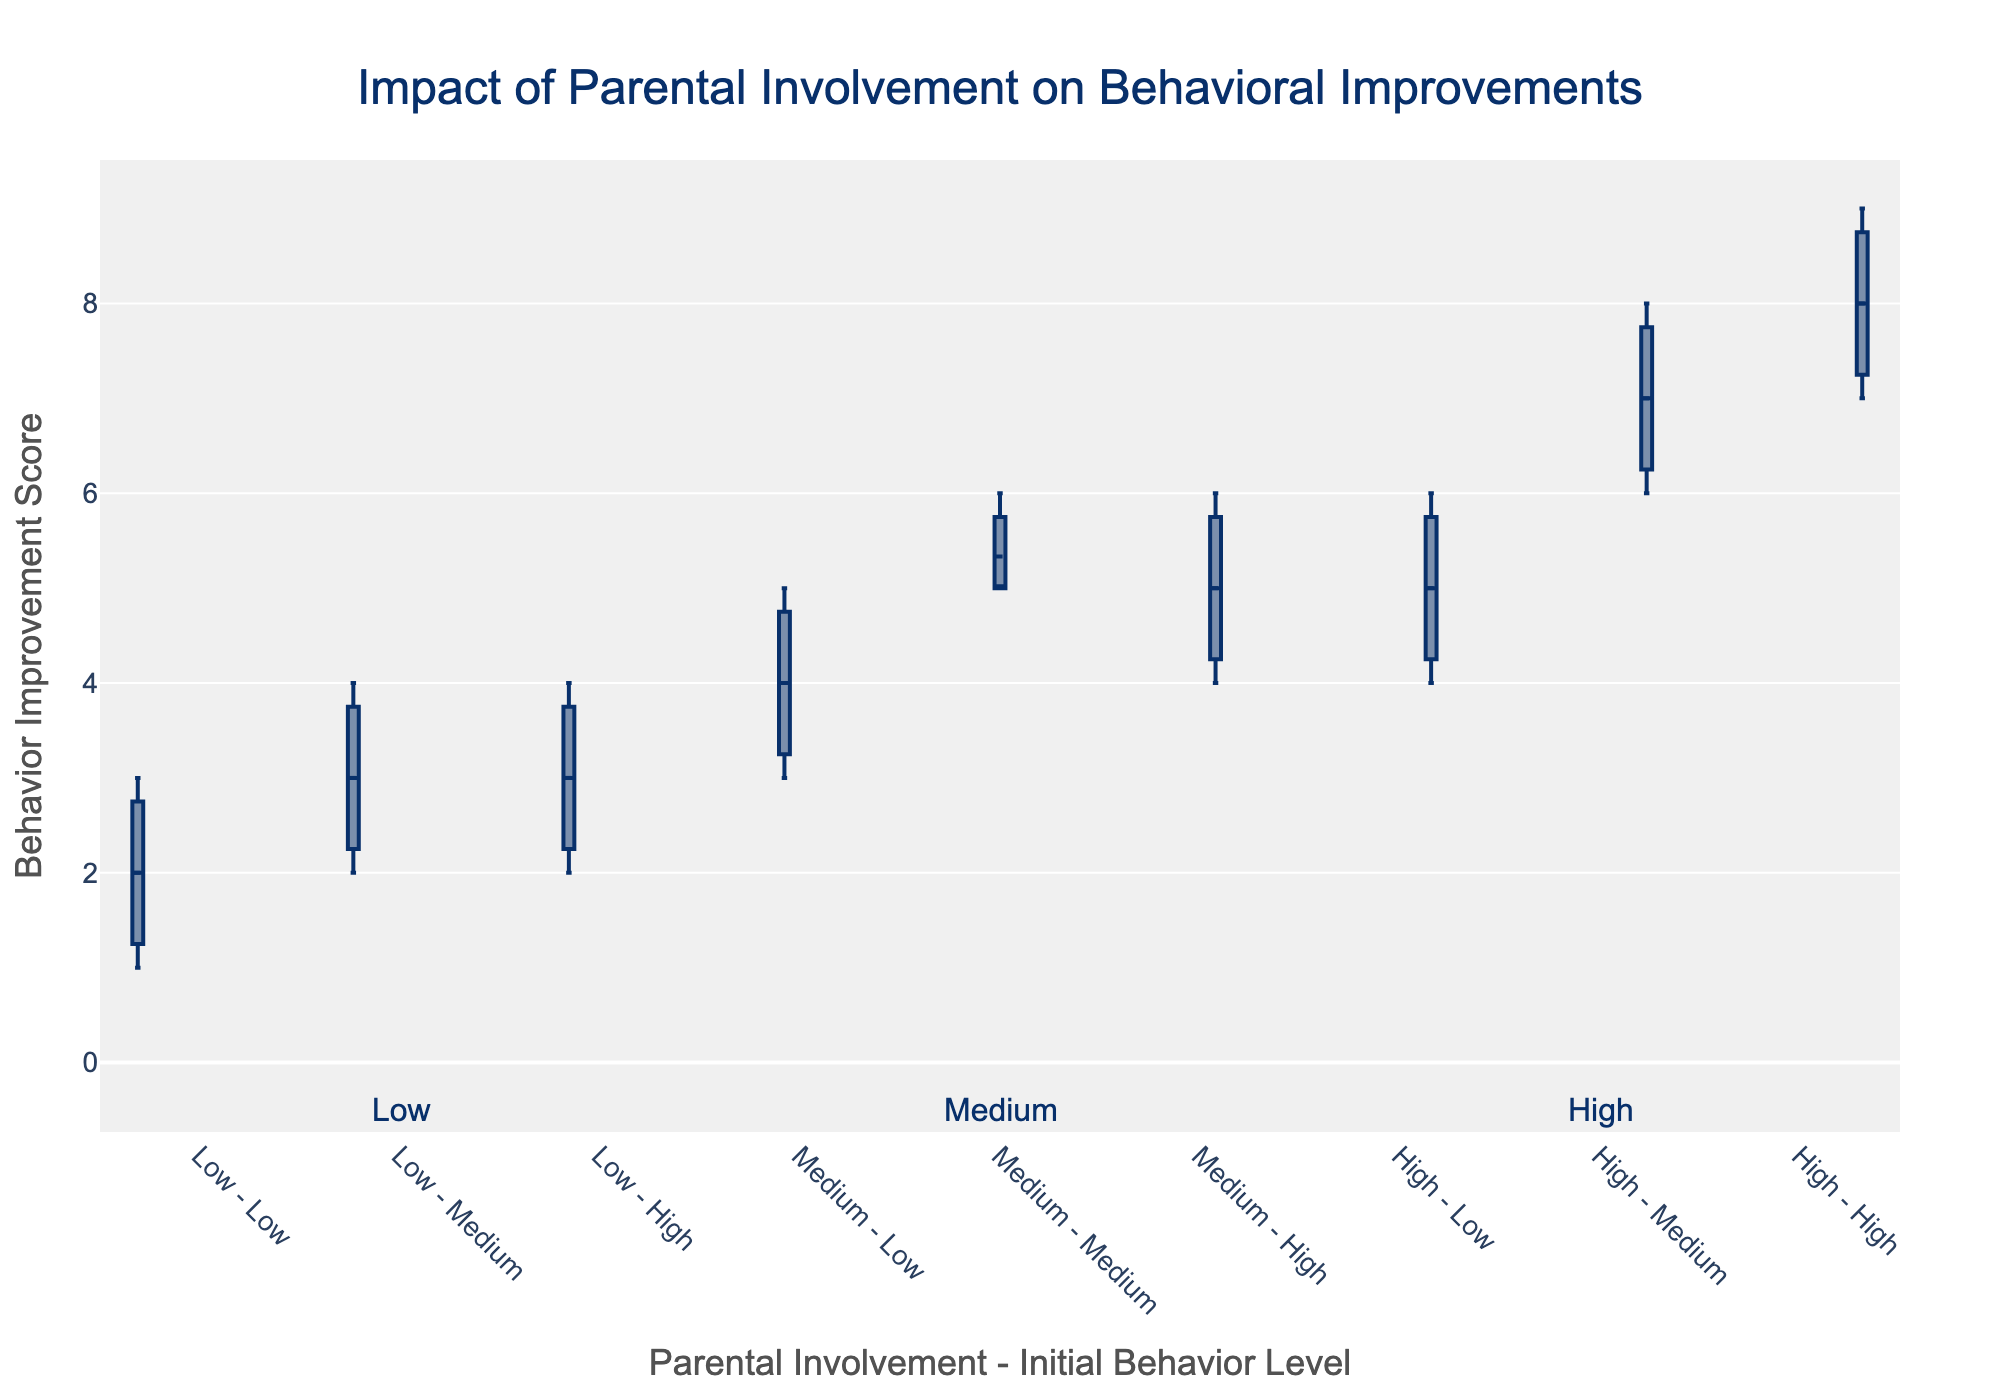What's the title of the figure? The title is often found at the top of the plot, and it explains what the figure is about. By looking at the figure, the title can be read directly.
Answer: Impact of Parental Involvement on Behavioral Improvements What is the y-axis label? The y-axis label is written along the vertical axis and describes what is being measured. You would read this directly from the axis label in the figure.
Answer: Behavior Improvement Score Which group shows the highest median behavior improvement score? In a box plot, the median is indicated by the line inside the box. By comparing the medians of all the groups, you can see which one is the highest.
Answer: High - High Which group shows the lowest median behavior improvement score? Again, by examining the lines inside the boxes and comparing them, the box with the lowest line represents the group with the lowest median score.
Answer: Low - Low How does the behavior improvement score range for high initial behavior levels compare across different levels of parental involvement? To compare the ranges, look at the lengths of the boxes and whiskers for 'High' initial behavior level in each parental involvement group. Check how these ranges extend between the minimum and maximum values.
Answer: High involvement: 7-9, Medium involvement: 4-6, Low involvement: 2-4 What is the approximate average behavior improvement score for children with medium initial behavior levels and medium parental involvement? The box plots with means enabled show a dot around the center of each box plot. For the 'Medium - Medium' group, find this dot to determine the average.
Answer: 5.33 Is there a trend in behavior improvement with increasing parental involvement within each initial behavior level? To identify the trend, look at each initial behavior level and observe how the median line (or the central line within each box) moves with an increase in parental involvement.
Answer: Yes, generally higher parental involvement leads to higher behavior improvement What is the interquartile range (IQR) for the group with low initial behavior level and low parental involvement? The IQR is the range between the first quartile (bottom of the box) and the third quartile (top of the box). For 'Low - Low', check these boundaries on the box plot.
Answer: 1-3 Which groups show outliers, if any? Outliers are points that lie outside the whiskers of a box plot. Scan each group and identify any points that lie at a distance from the whiskers.
Answer: None Comparing high parental involvement across different initial behavior levels, which group has the smallest range of behavior improvement scores? Ranges are indicated by the length of the whiskers and the box. Compare these ranges within the 'High' parental involvement across the initial behavior levels to find the smallest.
Answer: High initial behavior level 